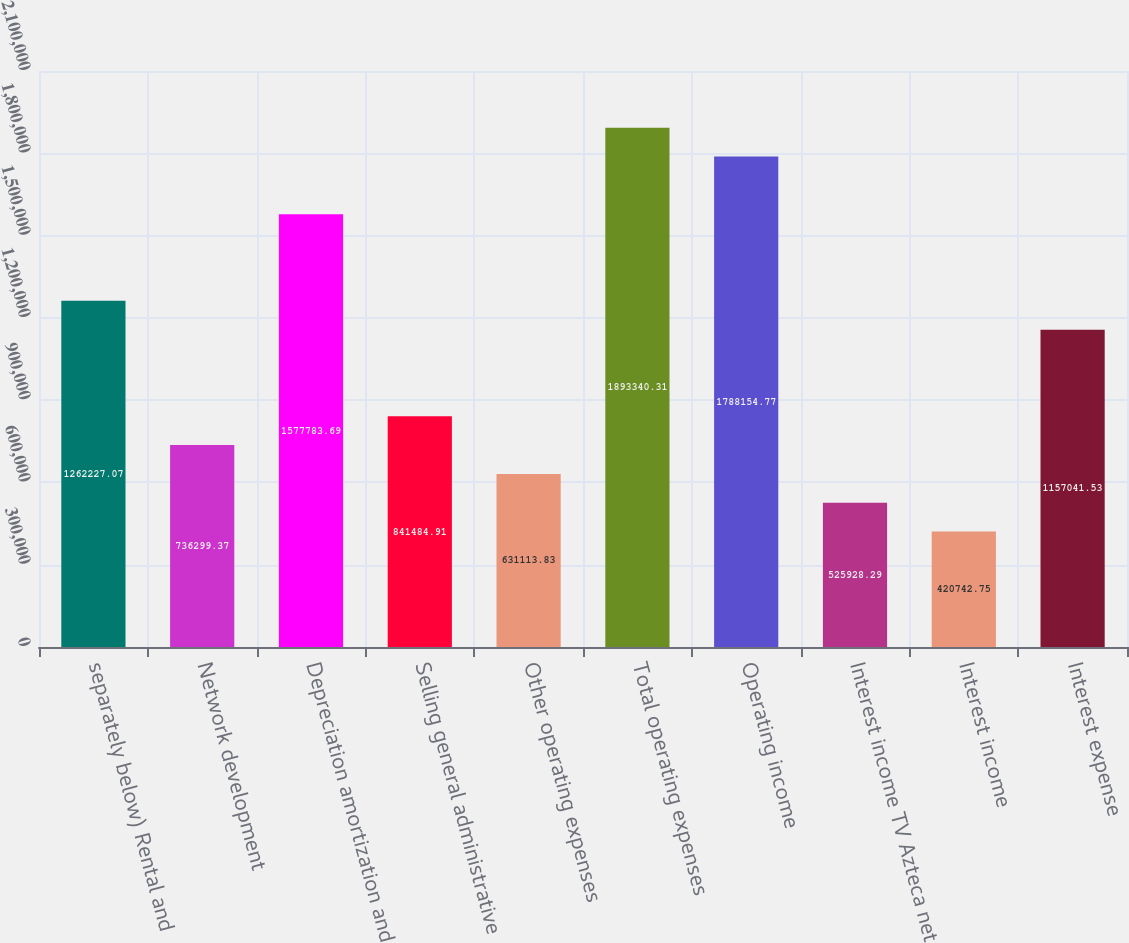<chart> <loc_0><loc_0><loc_500><loc_500><bar_chart><fcel>separately below) Rental and<fcel>Network development<fcel>Depreciation amortization and<fcel>Selling general administrative<fcel>Other operating expenses<fcel>Total operating expenses<fcel>Operating income<fcel>Interest income TV Azteca net<fcel>Interest income<fcel>Interest expense<nl><fcel>1.26223e+06<fcel>736299<fcel>1.57778e+06<fcel>841485<fcel>631114<fcel>1.89334e+06<fcel>1.78815e+06<fcel>525928<fcel>420743<fcel>1.15704e+06<nl></chart> 